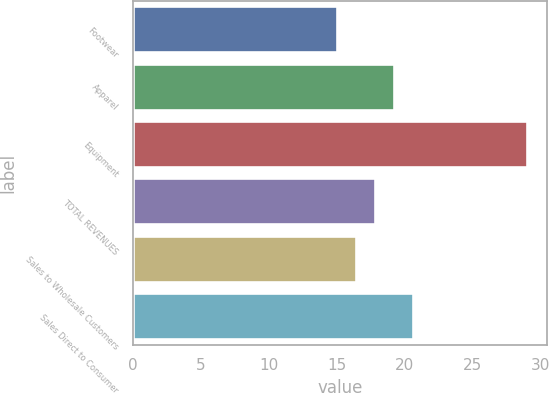Convert chart. <chart><loc_0><loc_0><loc_500><loc_500><bar_chart><fcel>Footwear<fcel>Apparel<fcel>Equipment<fcel>TOTAL REVENUES<fcel>Sales to Wholesale Customers<fcel>Sales Direct to Consumer<nl><fcel>15<fcel>19.2<fcel>29<fcel>17.8<fcel>16.4<fcel>20.6<nl></chart> 